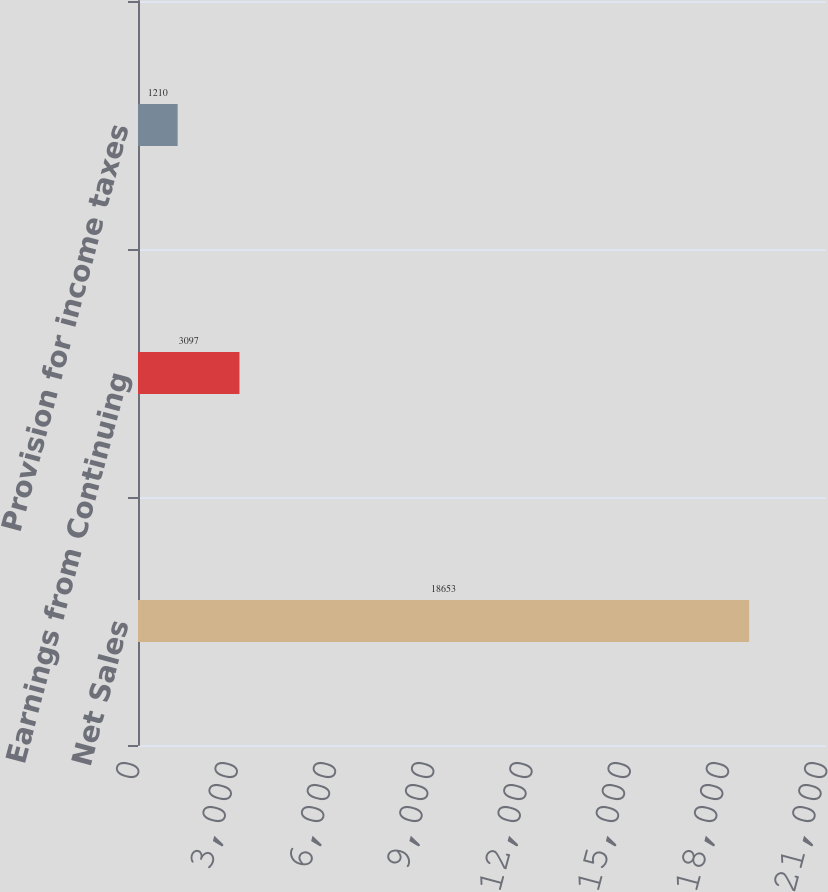Convert chart to OTSL. <chart><loc_0><loc_0><loc_500><loc_500><bar_chart><fcel>Net Sales<fcel>Earnings from Continuing<fcel>Provision for income taxes<nl><fcel>18653<fcel>3097<fcel>1210<nl></chart> 